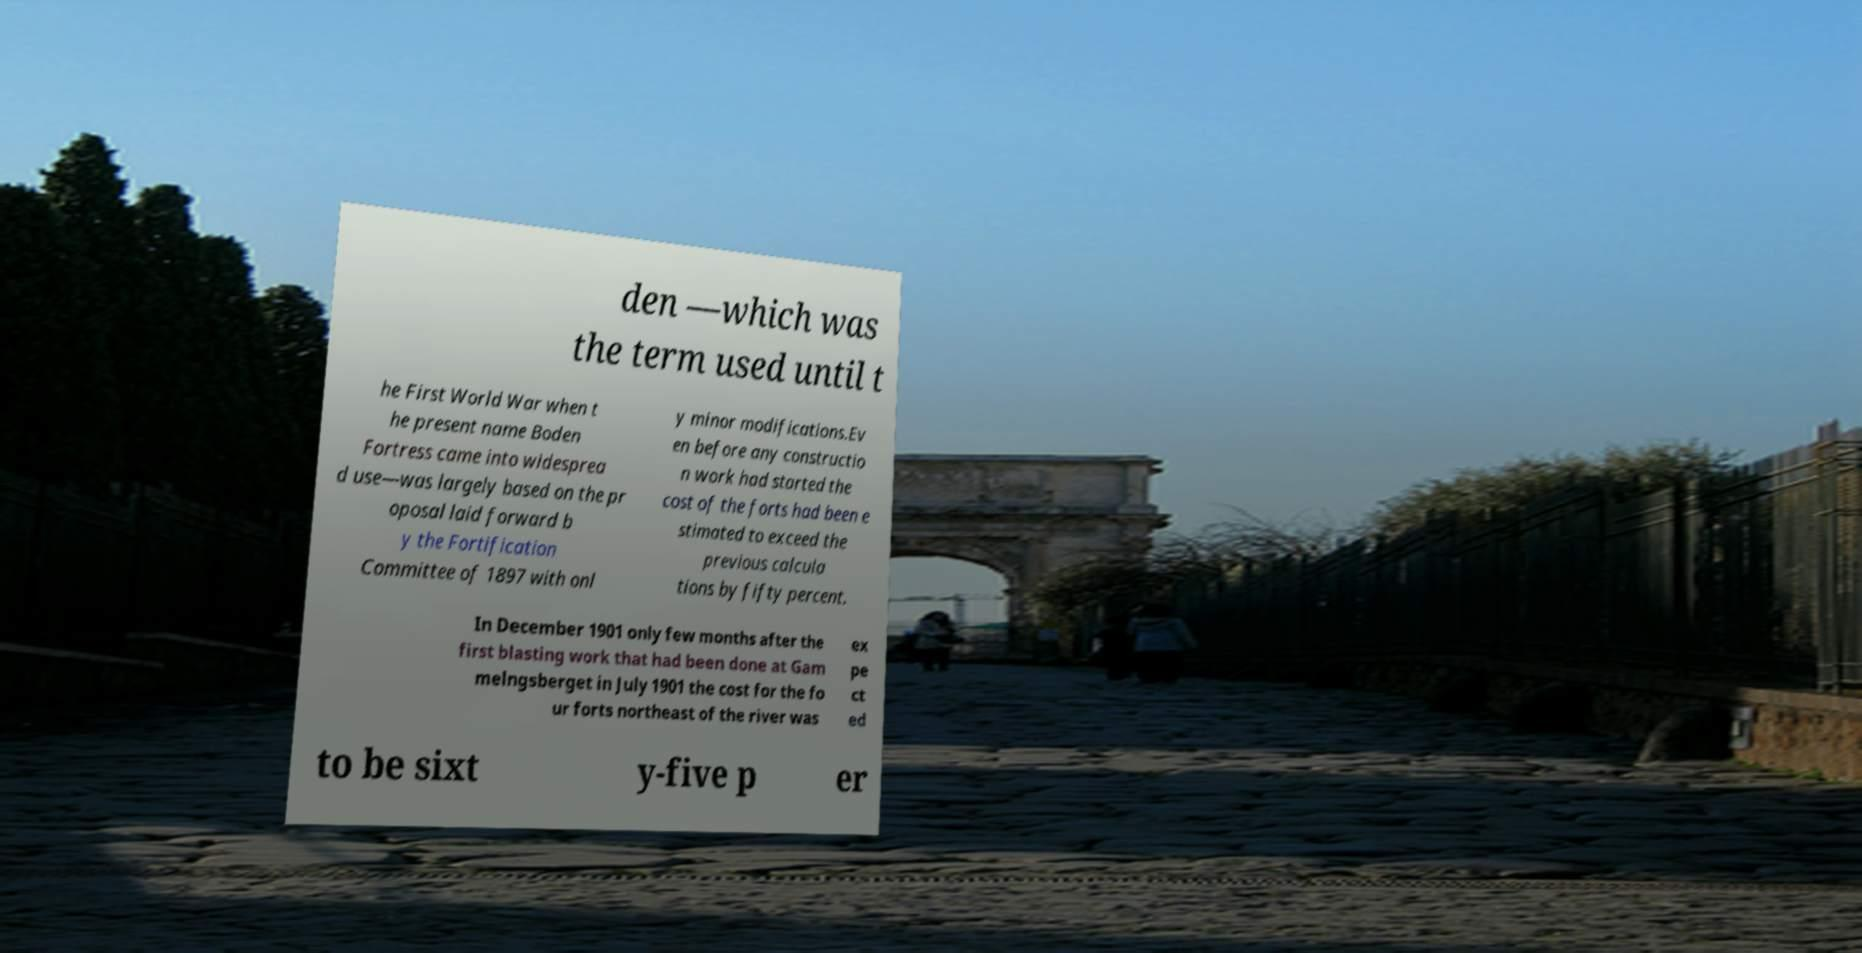Could you extract and type out the text from this image? den —which was the term used until t he First World War when t he present name Boden Fortress came into widesprea d use—was largely based on the pr oposal laid forward b y the Fortification Committee of 1897 with onl y minor modifications.Ev en before any constructio n work had started the cost of the forts had been e stimated to exceed the previous calcula tions by fifty percent. In December 1901 only few months after the first blasting work that had been done at Gam melngsberget in July 1901 the cost for the fo ur forts northeast of the river was ex pe ct ed to be sixt y-five p er 